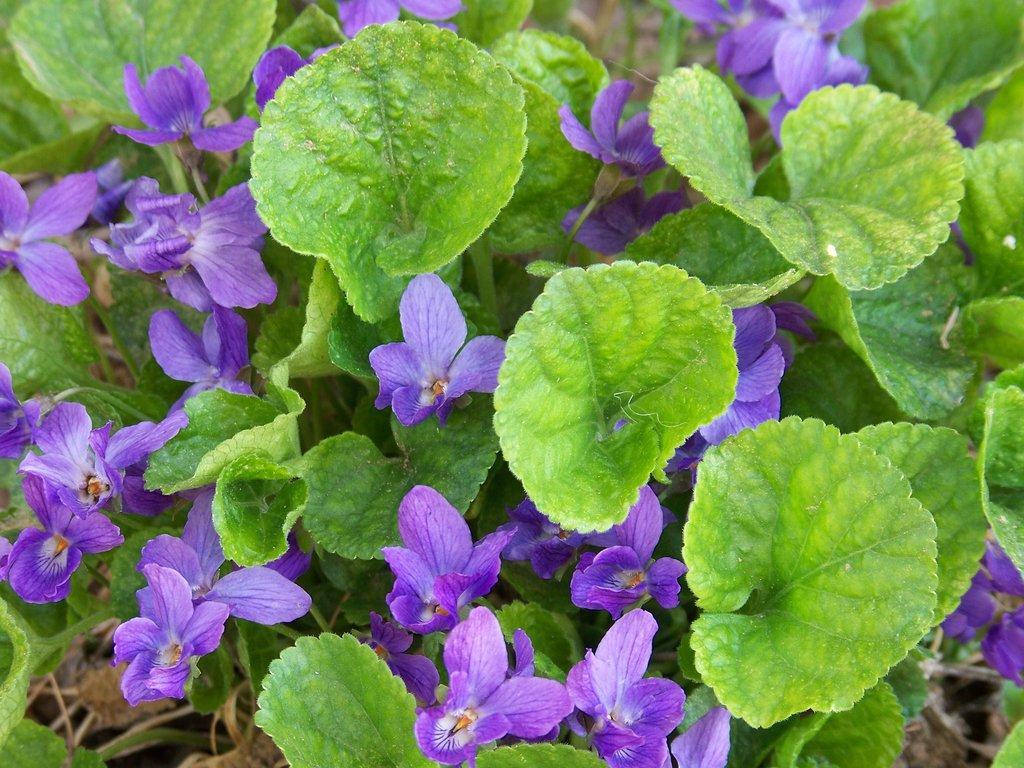How would you summarize this image in a sentence or two? In this picture we can observe violet color flowers. There are green color leaves. 